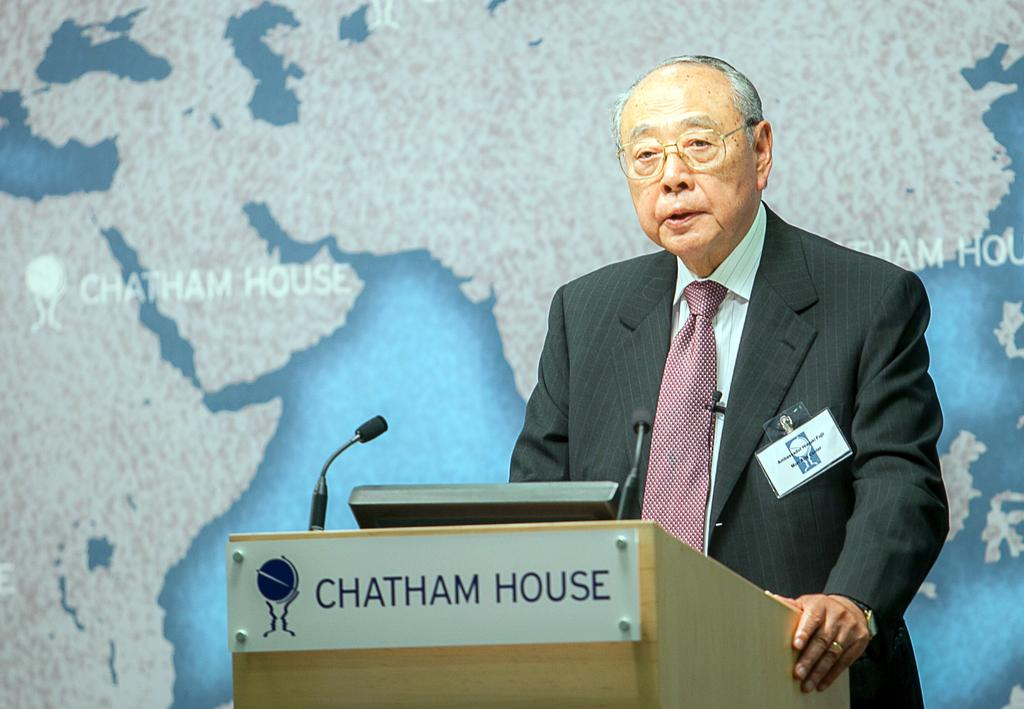What is the man in the image doing near the podium? The man is standing near a podium in the image. What is the man holding or using for speaking in the image? There is a microphone with a stand in the image. What type of clothing is the man wearing in the image? The man is wearing a formal suit in the image. What can be seen in the background of the image? There is a map on a banner in the background of the image. Are there any giants present in the image? No, there are no giants present in the image. What type of protest is taking place in the image? There is no protest depicted in the image; it shows a man standing near a podium with a microphone and a map in the background. 